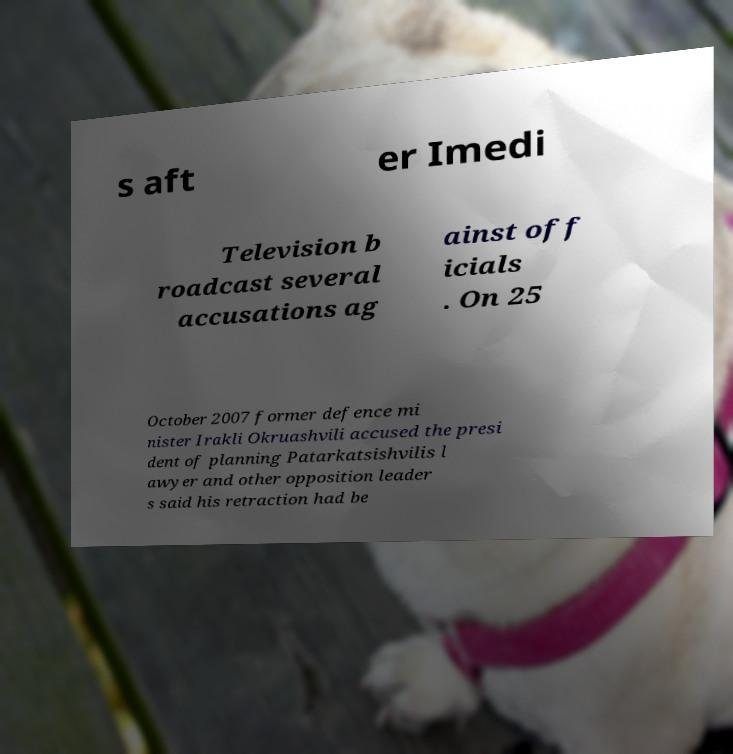Could you extract and type out the text from this image? s aft er Imedi Television b roadcast several accusations ag ainst off icials . On 25 October 2007 former defence mi nister Irakli Okruashvili accused the presi dent of planning Patarkatsishvilis l awyer and other opposition leader s said his retraction had be 